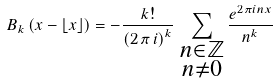Convert formula to latex. <formula><loc_0><loc_0><loc_500><loc_500>B _ { k } \left ( x - \lfloor x \rfloor \right ) = - \frac { k ! } { \left ( 2 \, \pi \, i \right ) ^ { k } } \, \sum _ { \substack { n \in \mathbb { Z } \\ n \neq 0 } } \frac { e ^ { 2 \pi i n x } } { n ^ { k } }</formula> 